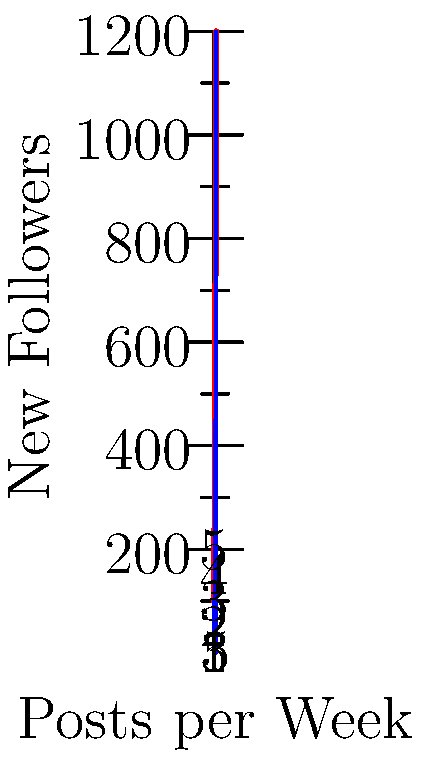Based on the bar graph showing the relationship between posting frequency and follower growth for an online museum's social media account, what is the approximate increase in new followers when moving from 3 to 4 posts per week? To determine the increase in new followers when moving from 3 to 4 posts per week, we need to:

1. Identify the number of new followers for 3 posts per week:
   At 3 posts per week, the bar reaches approximately 450 new followers.

2. Identify the number of new followers for 4 posts per week:
   At 4 posts per week, the bar reaches approximately 750 new followers.

3. Calculate the difference:
   $750 - 450 = 300$

Therefore, the approximate increase in new followers when moving from 3 to 4 posts per week is 300.
Answer: 300 new followers 